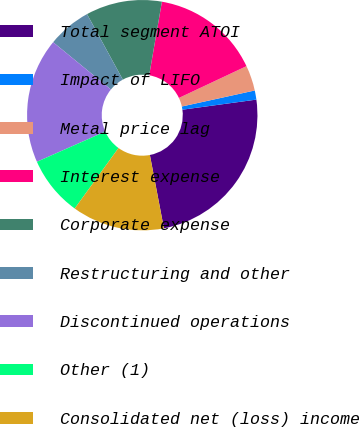Convert chart. <chart><loc_0><loc_0><loc_500><loc_500><pie_chart><fcel>Total segment ATOI<fcel>Impact of LIFO<fcel>Metal price lag<fcel>Interest expense<fcel>Corporate expense<fcel>Restructuring and other<fcel>Discontinued operations<fcel>Other (1)<fcel>Consolidated net (loss) income<nl><fcel>24.15%<fcel>1.28%<fcel>3.56%<fcel>15.27%<fcel>10.69%<fcel>6.12%<fcel>17.55%<fcel>8.4%<fcel>12.98%<nl></chart> 